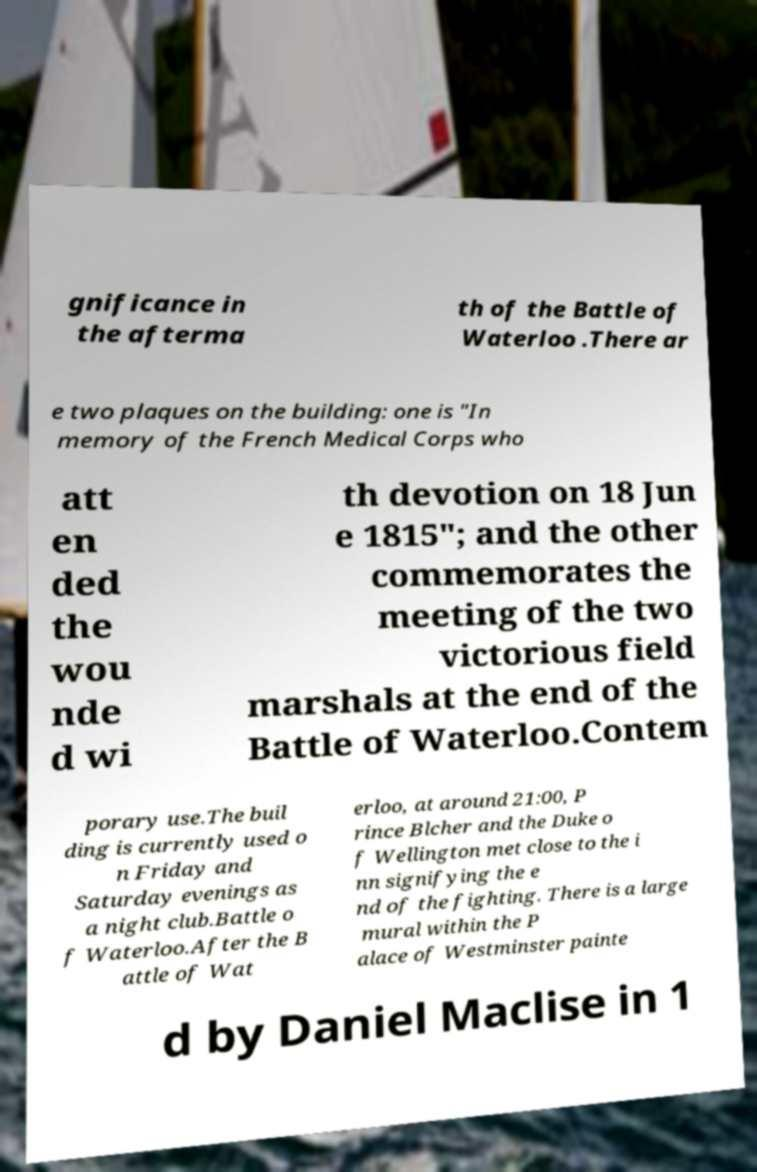There's text embedded in this image that I need extracted. Can you transcribe it verbatim? gnificance in the afterma th of the Battle of Waterloo .There ar e two plaques on the building: one is "In memory of the French Medical Corps who att en ded the wou nde d wi th devotion on 18 Jun e 1815"; and the other commemorates the meeting of the two victorious field marshals at the end of the Battle of Waterloo.Contem porary use.The buil ding is currently used o n Friday and Saturday evenings as a night club.Battle o f Waterloo.After the B attle of Wat erloo, at around 21:00, P rince Blcher and the Duke o f Wellington met close to the i nn signifying the e nd of the fighting. There is a large mural within the P alace of Westminster painte d by Daniel Maclise in 1 